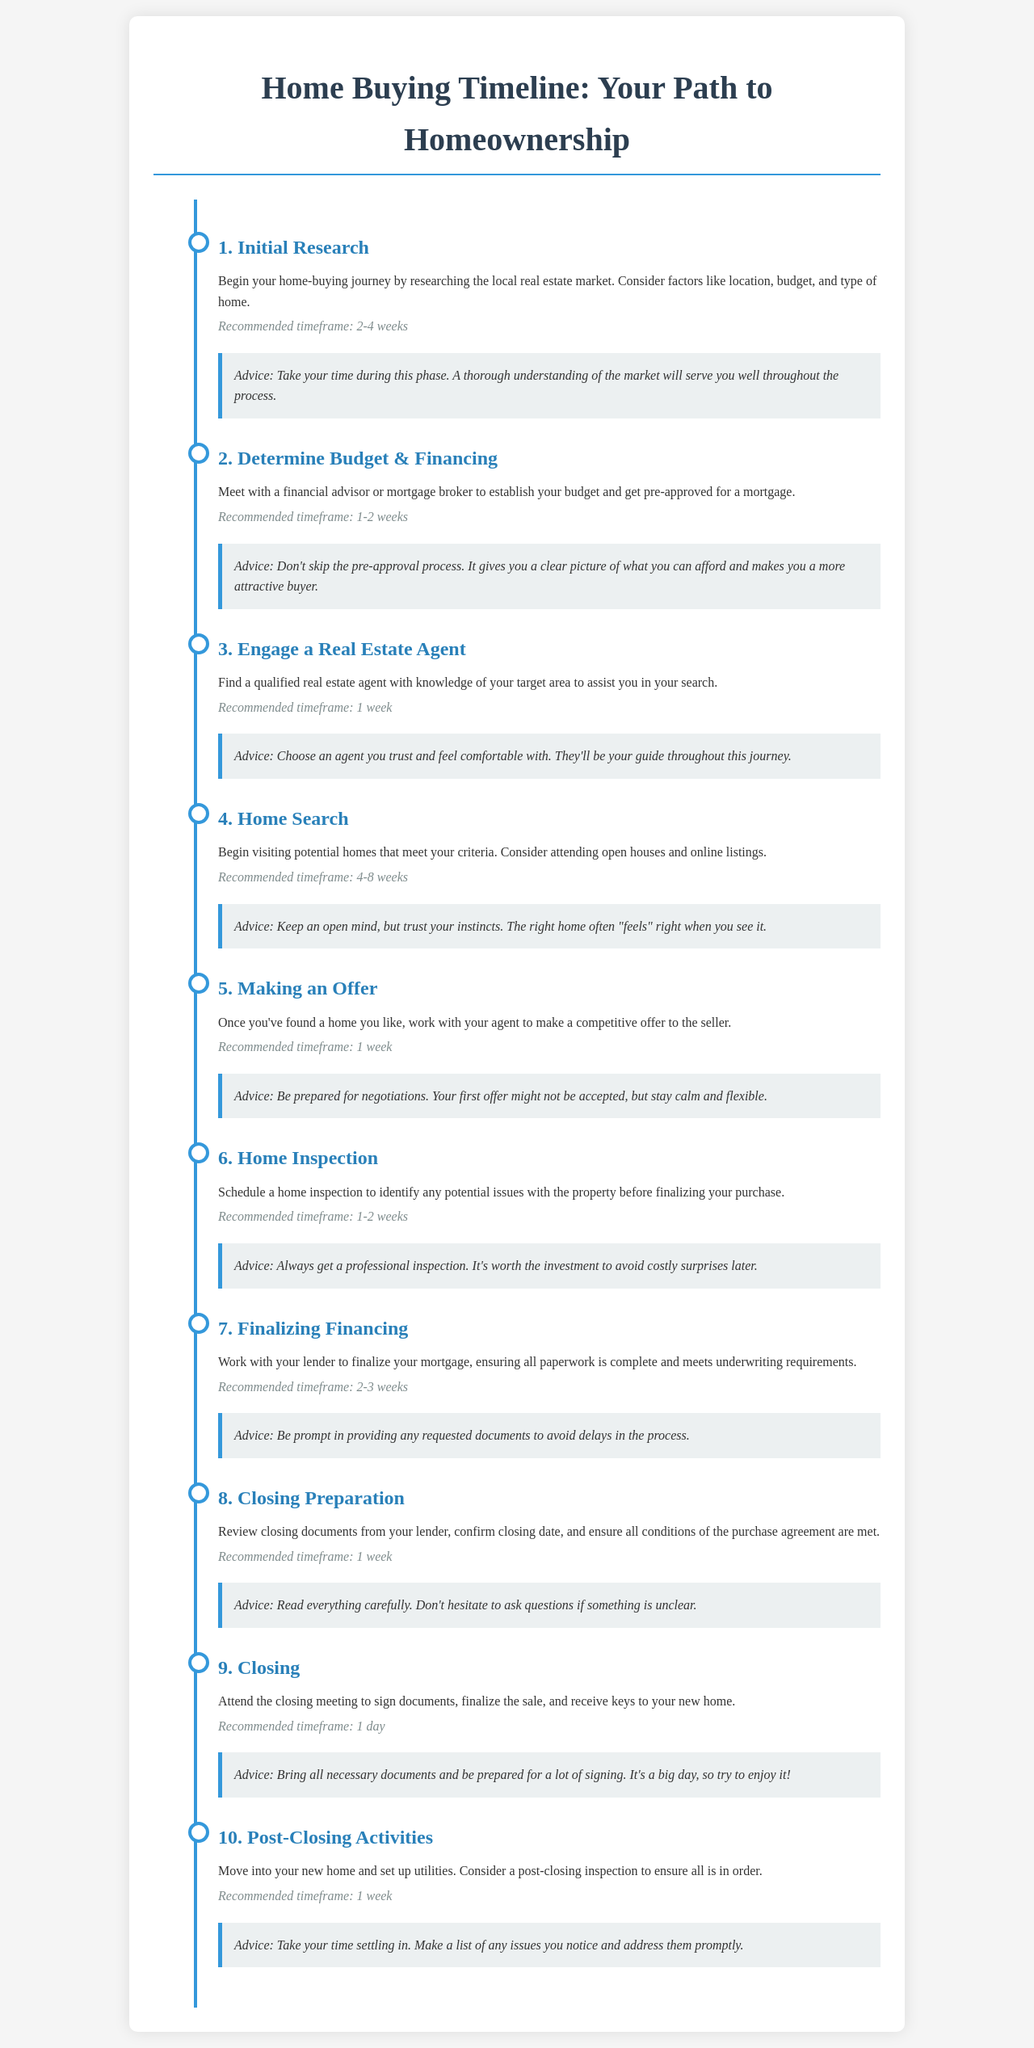What is the first milestone in the home-buying process? The first milestone mentioned in the document is "Initial Research," which begins the home-buying journey.
Answer: Initial Research What is the recommended timeframe for making an offer? The document states that the recommended timeframe for making an offer is 1 week.
Answer: 1 week How many weeks are suggested for the home search phase? The document indicates that the home search is recommended to take between 4 to 8 weeks.
Answer: 4-8 weeks What key document should be reviewed during the closing preparation? The closing documents from the lender should be reviewed during this phase as per the timeline.
Answer: Closing documents What is advised to do if something is unclear during closing preparation? The document advises that one should not hesitate to ask questions if something is unclear.
Answer: Ask questions Why is getting a pre-approval important? The document explains that getting pre-approved provides a clear picture of what you can afford, making you a more attractive buyer.
Answer: It clarifies affordability What is a recommended activity after closing? After closing, moving into your new home and setting up utilities is advised.
Answer: Move in and set up utilities What is suggested to do if issues are noticed post-closing? The document suggests making a list of any issues noticed and addressing them promptly.
Answer: Address issues promptly What is the duration of the home inspection phase? According to the document, the duration for the home inspection is recommended to be 1-2 weeks.
Answer: 1-2 weeks What final action occurs on the closing day? The final action on closing day, as stated in the document, is to sign documents and receive the keys to your new home.
Answer: Sign documents and receive keys 